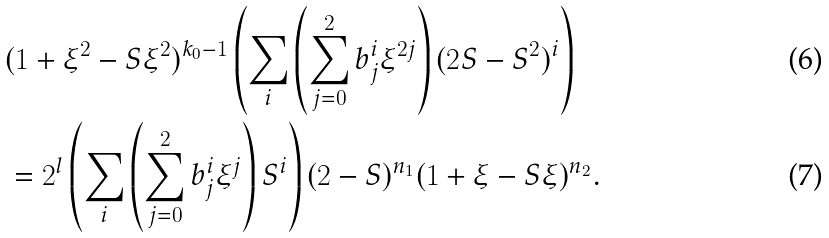<formula> <loc_0><loc_0><loc_500><loc_500>& ( 1 + \xi ^ { 2 } - S \xi ^ { 2 } ) ^ { k _ { 0 } - 1 } \left ( \sum _ { i } \left ( \sum _ { j = 0 } ^ { 2 } b ^ { i } _ { j } \xi ^ { 2 j } \right ) ( 2 S - S ^ { 2 } ) ^ { i } \right ) \\ & = 2 ^ { l } \left ( \sum _ { i } \left ( \sum _ { j = 0 } ^ { 2 } b ^ { i } _ { j } \xi ^ { j } \right ) S ^ { i } \right ) ( 2 - S ) ^ { n _ { 1 } } ( 1 + \xi - S \xi ) ^ { n _ { 2 } } .</formula> 